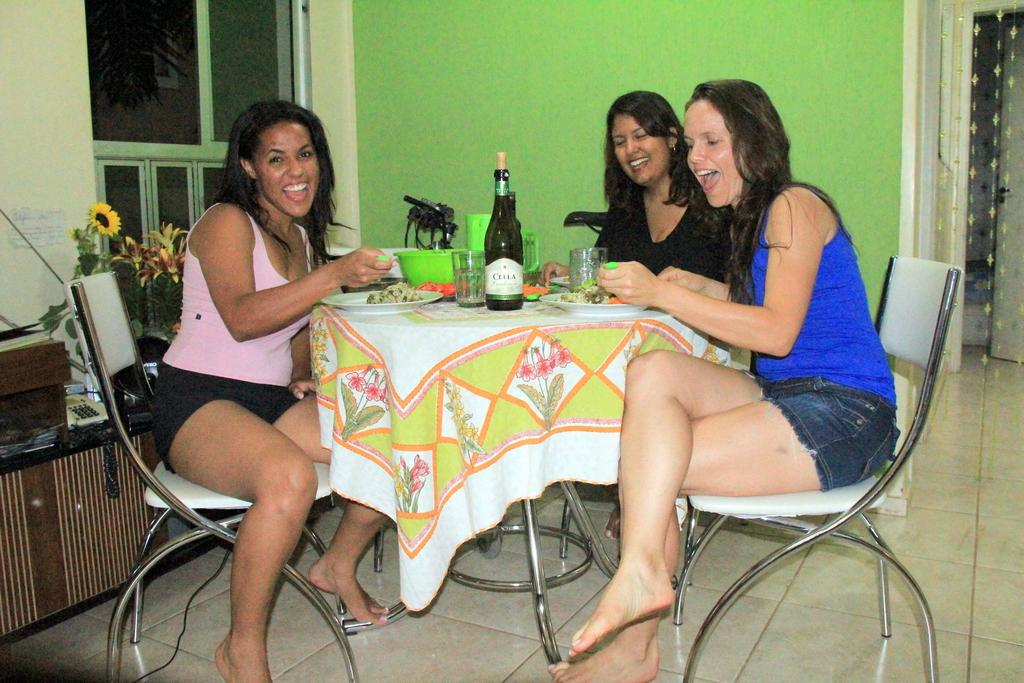How many women are present in the image? There are three women in the image. What are the women doing in the image? The women are sitting on chairs and having food. What can be seen on the table in the image? There is a wine bottle and wine glasses on the table. What is visible in the background of the image? There is a window and a wall in the background. What type of twig is being used as a utensil by one of the women in the image? There is no twig present in the image; the women are using conventional utensils for eating. 